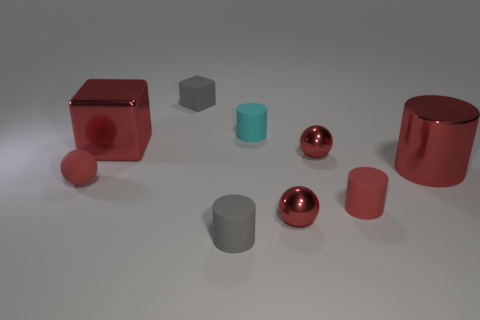The red rubber cylinder has what size?
Make the answer very short. Small. There is a block that is the same size as the matte sphere; what color is it?
Your answer should be very brief. Gray. Is there a small cylinder of the same color as the small rubber sphere?
Your response must be concise. Yes. What material is the gray block?
Provide a short and direct response. Rubber. What number of big gray shiny spheres are there?
Keep it short and to the point. 0. There is a big thing behind the large red cylinder; does it have the same color as the large shiny thing in front of the big red shiny block?
Provide a succinct answer. Yes. There is a rubber ball that is the same color as the large cylinder; what size is it?
Give a very brief answer. Small. What number of other things are there of the same size as the cyan cylinder?
Ensure brevity in your answer.  6. What color is the ball that is behind the red metal cylinder?
Provide a succinct answer. Red. Is the cylinder that is left of the cyan matte cylinder made of the same material as the small cyan object?
Offer a very short reply. Yes. 